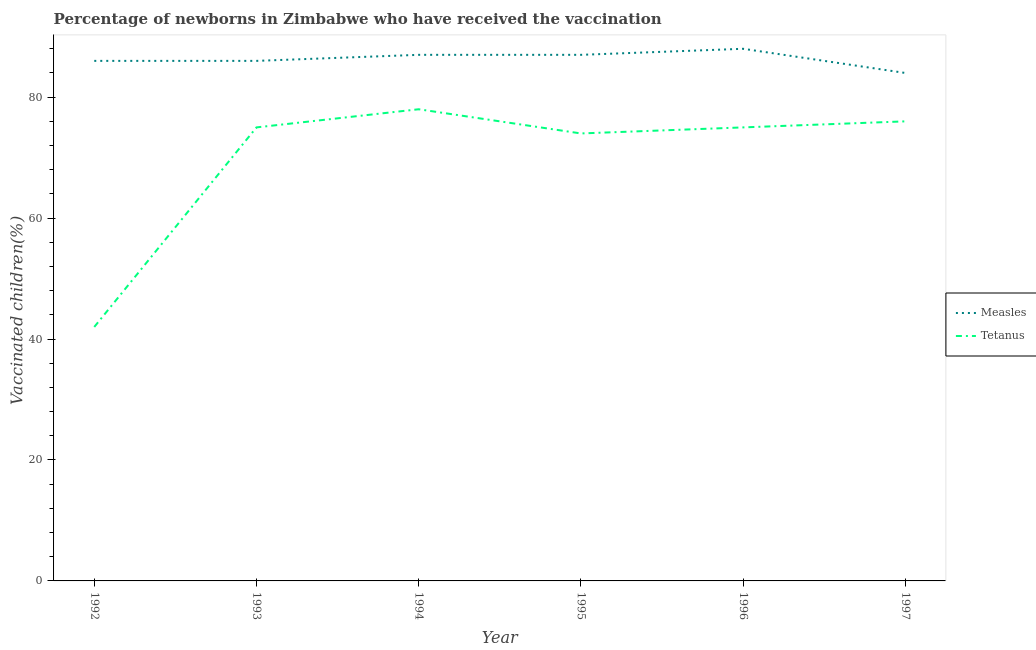What is the percentage of newborns who received vaccination for measles in 1997?
Provide a succinct answer. 84. Across all years, what is the maximum percentage of newborns who received vaccination for tetanus?
Your answer should be compact. 78. Across all years, what is the minimum percentage of newborns who received vaccination for tetanus?
Your answer should be compact. 42. In which year was the percentage of newborns who received vaccination for measles maximum?
Provide a short and direct response. 1996. In which year was the percentage of newborns who received vaccination for tetanus minimum?
Give a very brief answer. 1992. What is the total percentage of newborns who received vaccination for measles in the graph?
Your answer should be compact. 518. What is the difference between the percentage of newborns who received vaccination for measles in 1992 and that in 1994?
Offer a very short reply. -1. What is the difference between the percentage of newborns who received vaccination for measles in 1996 and the percentage of newborns who received vaccination for tetanus in 1993?
Your response must be concise. 13. What is the average percentage of newborns who received vaccination for measles per year?
Offer a terse response. 86.33. In the year 1993, what is the difference between the percentage of newborns who received vaccination for measles and percentage of newborns who received vaccination for tetanus?
Your response must be concise. 11. In how many years, is the percentage of newborns who received vaccination for tetanus greater than 76 %?
Your answer should be compact. 1. What is the ratio of the percentage of newborns who received vaccination for measles in 1993 to that in 1995?
Offer a very short reply. 0.99. Is the percentage of newborns who received vaccination for measles in 1994 less than that in 1997?
Offer a terse response. No. Is the difference between the percentage of newborns who received vaccination for measles in 1992 and 1997 greater than the difference between the percentage of newborns who received vaccination for tetanus in 1992 and 1997?
Provide a succinct answer. Yes. What is the difference between the highest and the second highest percentage of newborns who received vaccination for measles?
Give a very brief answer. 1. What is the difference between the highest and the lowest percentage of newborns who received vaccination for tetanus?
Keep it short and to the point. 36. Is the sum of the percentage of newborns who received vaccination for tetanus in 1993 and 1994 greater than the maximum percentage of newborns who received vaccination for measles across all years?
Give a very brief answer. Yes. Does the percentage of newborns who received vaccination for measles monotonically increase over the years?
Make the answer very short. No. Is the percentage of newborns who received vaccination for tetanus strictly greater than the percentage of newborns who received vaccination for measles over the years?
Your response must be concise. No. Is the percentage of newborns who received vaccination for tetanus strictly less than the percentage of newborns who received vaccination for measles over the years?
Your response must be concise. Yes. How many lines are there?
Keep it short and to the point. 2. How many years are there in the graph?
Offer a terse response. 6. What is the difference between two consecutive major ticks on the Y-axis?
Provide a short and direct response. 20. Are the values on the major ticks of Y-axis written in scientific E-notation?
Provide a succinct answer. No. Does the graph contain any zero values?
Your answer should be compact. No. Where does the legend appear in the graph?
Keep it short and to the point. Center right. How many legend labels are there?
Provide a short and direct response. 2. How are the legend labels stacked?
Give a very brief answer. Vertical. What is the title of the graph?
Your answer should be very brief. Percentage of newborns in Zimbabwe who have received the vaccination. What is the label or title of the X-axis?
Ensure brevity in your answer.  Year. What is the label or title of the Y-axis?
Your response must be concise. Vaccinated children(%)
. What is the Vaccinated children(%)
 in Tetanus in 1992?
Your answer should be very brief. 42. What is the Vaccinated children(%)
 of Measles in 1994?
Make the answer very short. 87. What is the Vaccinated children(%)
 of Tetanus in 1994?
Provide a succinct answer. 78. What is the Vaccinated children(%)
 in Measles in 1995?
Ensure brevity in your answer.  87. What is the Vaccinated children(%)
 in Tetanus in 1995?
Provide a succinct answer. 74. What is the Vaccinated children(%)
 in Measles in 1996?
Your answer should be compact. 88. What is the Vaccinated children(%)
 in Tetanus in 1996?
Your answer should be compact. 75. What is the Vaccinated children(%)
 in Measles in 1997?
Your answer should be very brief. 84. Across all years, what is the minimum Vaccinated children(%)
 of Tetanus?
Provide a succinct answer. 42. What is the total Vaccinated children(%)
 of Measles in the graph?
Ensure brevity in your answer.  518. What is the total Vaccinated children(%)
 of Tetanus in the graph?
Make the answer very short. 420. What is the difference between the Vaccinated children(%)
 of Measles in 1992 and that in 1993?
Keep it short and to the point. 0. What is the difference between the Vaccinated children(%)
 of Tetanus in 1992 and that in 1993?
Make the answer very short. -33. What is the difference between the Vaccinated children(%)
 of Measles in 1992 and that in 1994?
Your response must be concise. -1. What is the difference between the Vaccinated children(%)
 of Tetanus in 1992 and that in 1994?
Offer a very short reply. -36. What is the difference between the Vaccinated children(%)
 of Tetanus in 1992 and that in 1995?
Provide a short and direct response. -32. What is the difference between the Vaccinated children(%)
 in Tetanus in 1992 and that in 1996?
Offer a very short reply. -33. What is the difference between the Vaccinated children(%)
 in Tetanus in 1992 and that in 1997?
Make the answer very short. -34. What is the difference between the Vaccinated children(%)
 of Measles in 1993 and that in 1994?
Your answer should be compact. -1. What is the difference between the Vaccinated children(%)
 of Tetanus in 1993 and that in 1994?
Your response must be concise. -3. What is the difference between the Vaccinated children(%)
 in Measles in 1993 and that in 1995?
Keep it short and to the point. -1. What is the difference between the Vaccinated children(%)
 of Tetanus in 1993 and that in 1996?
Your answer should be very brief. 0. What is the difference between the Vaccinated children(%)
 in Measles in 1993 and that in 1997?
Offer a very short reply. 2. What is the difference between the Vaccinated children(%)
 of Tetanus in 1993 and that in 1997?
Your response must be concise. -1. What is the difference between the Vaccinated children(%)
 in Measles in 1994 and that in 1995?
Make the answer very short. 0. What is the difference between the Vaccinated children(%)
 of Tetanus in 1994 and that in 1995?
Offer a terse response. 4. What is the difference between the Vaccinated children(%)
 in Measles in 1994 and that in 1996?
Your answer should be very brief. -1. What is the difference between the Vaccinated children(%)
 of Tetanus in 1994 and that in 1996?
Ensure brevity in your answer.  3. What is the difference between the Vaccinated children(%)
 in Tetanus in 1995 and that in 1996?
Your response must be concise. -1. What is the difference between the Vaccinated children(%)
 in Measles in 1992 and the Vaccinated children(%)
 in Tetanus in 1993?
Make the answer very short. 11. What is the difference between the Vaccinated children(%)
 in Measles in 1992 and the Vaccinated children(%)
 in Tetanus in 1996?
Ensure brevity in your answer.  11. What is the difference between the Vaccinated children(%)
 of Measles in 1992 and the Vaccinated children(%)
 of Tetanus in 1997?
Provide a short and direct response. 10. What is the difference between the Vaccinated children(%)
 of Measles in 1993 and the Vaccinated children(%)
 of Tetanus in 1994?
Make the answer very short. 8. What is the difference between the Vaccinated children(%)
 in Measles in 1993 and the Vaccinated children(%)
 in Tetanus in 1996?
Keep it short and to the point. 11. What is the difference between the Vaccinated children(%)
 in Measles in 1994 and the Vaccinated children(%)
 in Tetanus in 1995?
Your response must be concise. 13. What is the difference between the Vaccinated children(%)
 of Measles in 1994 and the Vaccinated children(%)
 of Tetanus in 1996?
Your answer should be compact. 12. What is the difference between the Vaccinated children(%)
 of Measles in 1995 and the Vaccinated children(%)
 of Tetanus in 1996?
Offer a terse response. 12. What is the difference between the Vaccinated children(%)
 of Measles in 1995 and the Vaccinated children(%)
 of Tetanus in 1997?
Your answer should be very brief. 11. What is the average Vaccinated children(%)
 of Measles per year?
Keep it short and to the point. 86.33. In the year 1992, what is the difference between the Vaccinated children(%)
 in Measles and Vaccinated children(%)
 in Tetanus?
Your response must be concise. 44. In the year 1994, what is the difference between the Vaccinated children(%)
 of Measles and Vaccinated children(%)
 of Tetanus?
Provide a short and direct response. 9. In the year 1995, what is the difference between the Vaccinated children(%)
 in Measles and Vaccinated children(%)
 in Tetanus?
Provide a succinct answer. 13. In the year 1997, what is the difference between the Vaccinated children(%)
 in Measles and Vaccinated children(%)
 in Tetanus?
Keep it short and to the point. 8. What is the ratio of the Vaccinated children(%)
 in Tetanus in 1992 to that in 1993?
Your answer should be very brief. 0.56. What is the ratio of the Vaccinated children(%)
 of Measles in 1992 to that in 1994?
Your answer should be very brief. 0.99. What is the ratio of the Vaccinated children(%)
 of Tetanus in 1992 to that in 1994?
Your response must be concise. 0.54. What is the ratio of the Vaccinated children(%)
 of Tetanus in 1992 to that in 1995?
Offer a terse response. 0.57. What is the ratio of the Vaccinated children(%)
 in Measles in 1992 to that in 1996?
Your answer should be very brief. 0.98. What is the ratio of the Vaccinated children(%)
 of Tetanus in 1992 to that in 1996?
Offer a very short reply. 0.56. What is the ratio of the Vaccinated children(%)
 of Measles in 1992 to that in 1997?
Your answer should be compact. 1.02. What is the ratio of the Vaccinated children(%)
 of Tetanus in 1992 to that in 1997?
Make the answer very short. 0.55. What is the ratio of the Vaccinated children(%)
 in Tetanus in 1993 to that in 1994?
Keep it short and to the point. 0.96. What is the ratio of the Vaccinated children(%)
 in Measles in 1993 to that in 1995?
Provide a short and direct response. 0.99. What is the ratio of the Vaccinated children(%)
 of Tetanus in 1993 to that in 1995?
Your answer should be very brief. 1.01. What is the ratio of the Vaccinated children(%)
 of Measles in 1993 to that in 1996?
Provide a short and direct response. 0.98. What is the ratio of the Vaccinated children(%)
 in Tetanus in 1993 to that in 1996?
Your answer should be very brief. 1. What is the ratio of the Vaccinated children(%)
 of Measles in 1993 to that in 1997?
Offer a terse response. 1.02. What is the ratio of the Vaccinated children(%)
 in Tetanus in 1993 to that in 1997?
Provide a short and direct response. 0.99. What is the ratio of the Vaccinated children(%)
 in Tetanus in 1994 to that in 1995?
Give a very brief answer. 1.05. What is the ratio of the Vaccinated children(%)
 of Measles in 1994 to that in 1996?
Offer a terse response. 0.99. What is the ratio of the Vaccinated children(%)
 of Measles in 1994 to that in 1997?
Ensure brevity in your answer.  1.04. What is the ratio of the Vaccinated children(%)
 of Tetanus in 1994 to that in 1997?
Ensure brevity in your answer.  1.03. What is the ratio of the Vaccinated children(%)
 in Tetanus in 1995 to that in 1996?
Provide a short and direct response. 0.99. What is the ratio of the Vaccinated children(%)
 of Measles in 1995 to that in 1997?
Ensure brevity in your answer.  1.04. What is the ratio of the Vaccinated children(%)
 of Tetanus in 1995 to that in 1997?
Your answer should be very brief. 0.97. What is the ratio of the Vaccinated children(%)
 in Measles in 1996 to that in 1997?
Your response must be concise. 1.05. What is the difference between the highest and the second highest Vaccinated children(%)
 of Tetanus?
Your response must be concise. 2. What is the difference between the highest and the lowest Vaccinated children(%)
 in Tetanus?
Provide a short and direct response. 36. 